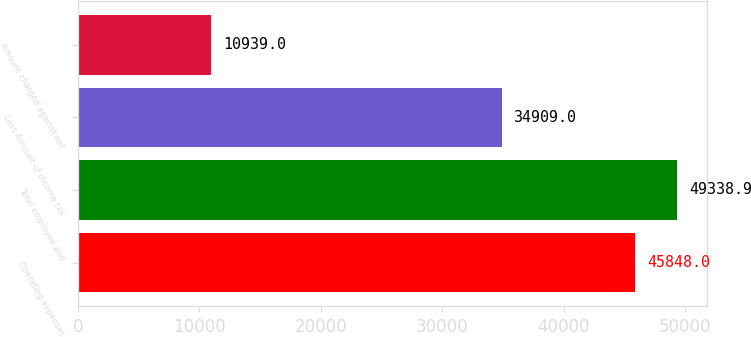<chart> <loc_0><loc_0><loc_500><loc_500><bar_chart><fcel>Operating expenses<fcel>Total employee and<fcel>Less Amount of income tax<fcel>Amount charged against net<nl><fcel>45848<fcel>49338.9<fcel>34909<fcel>10939<nl></chart> 